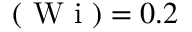<formula> <loc_0><loc_0><loc_500><loc_500>( W i ) = 0 . 2</formula> 